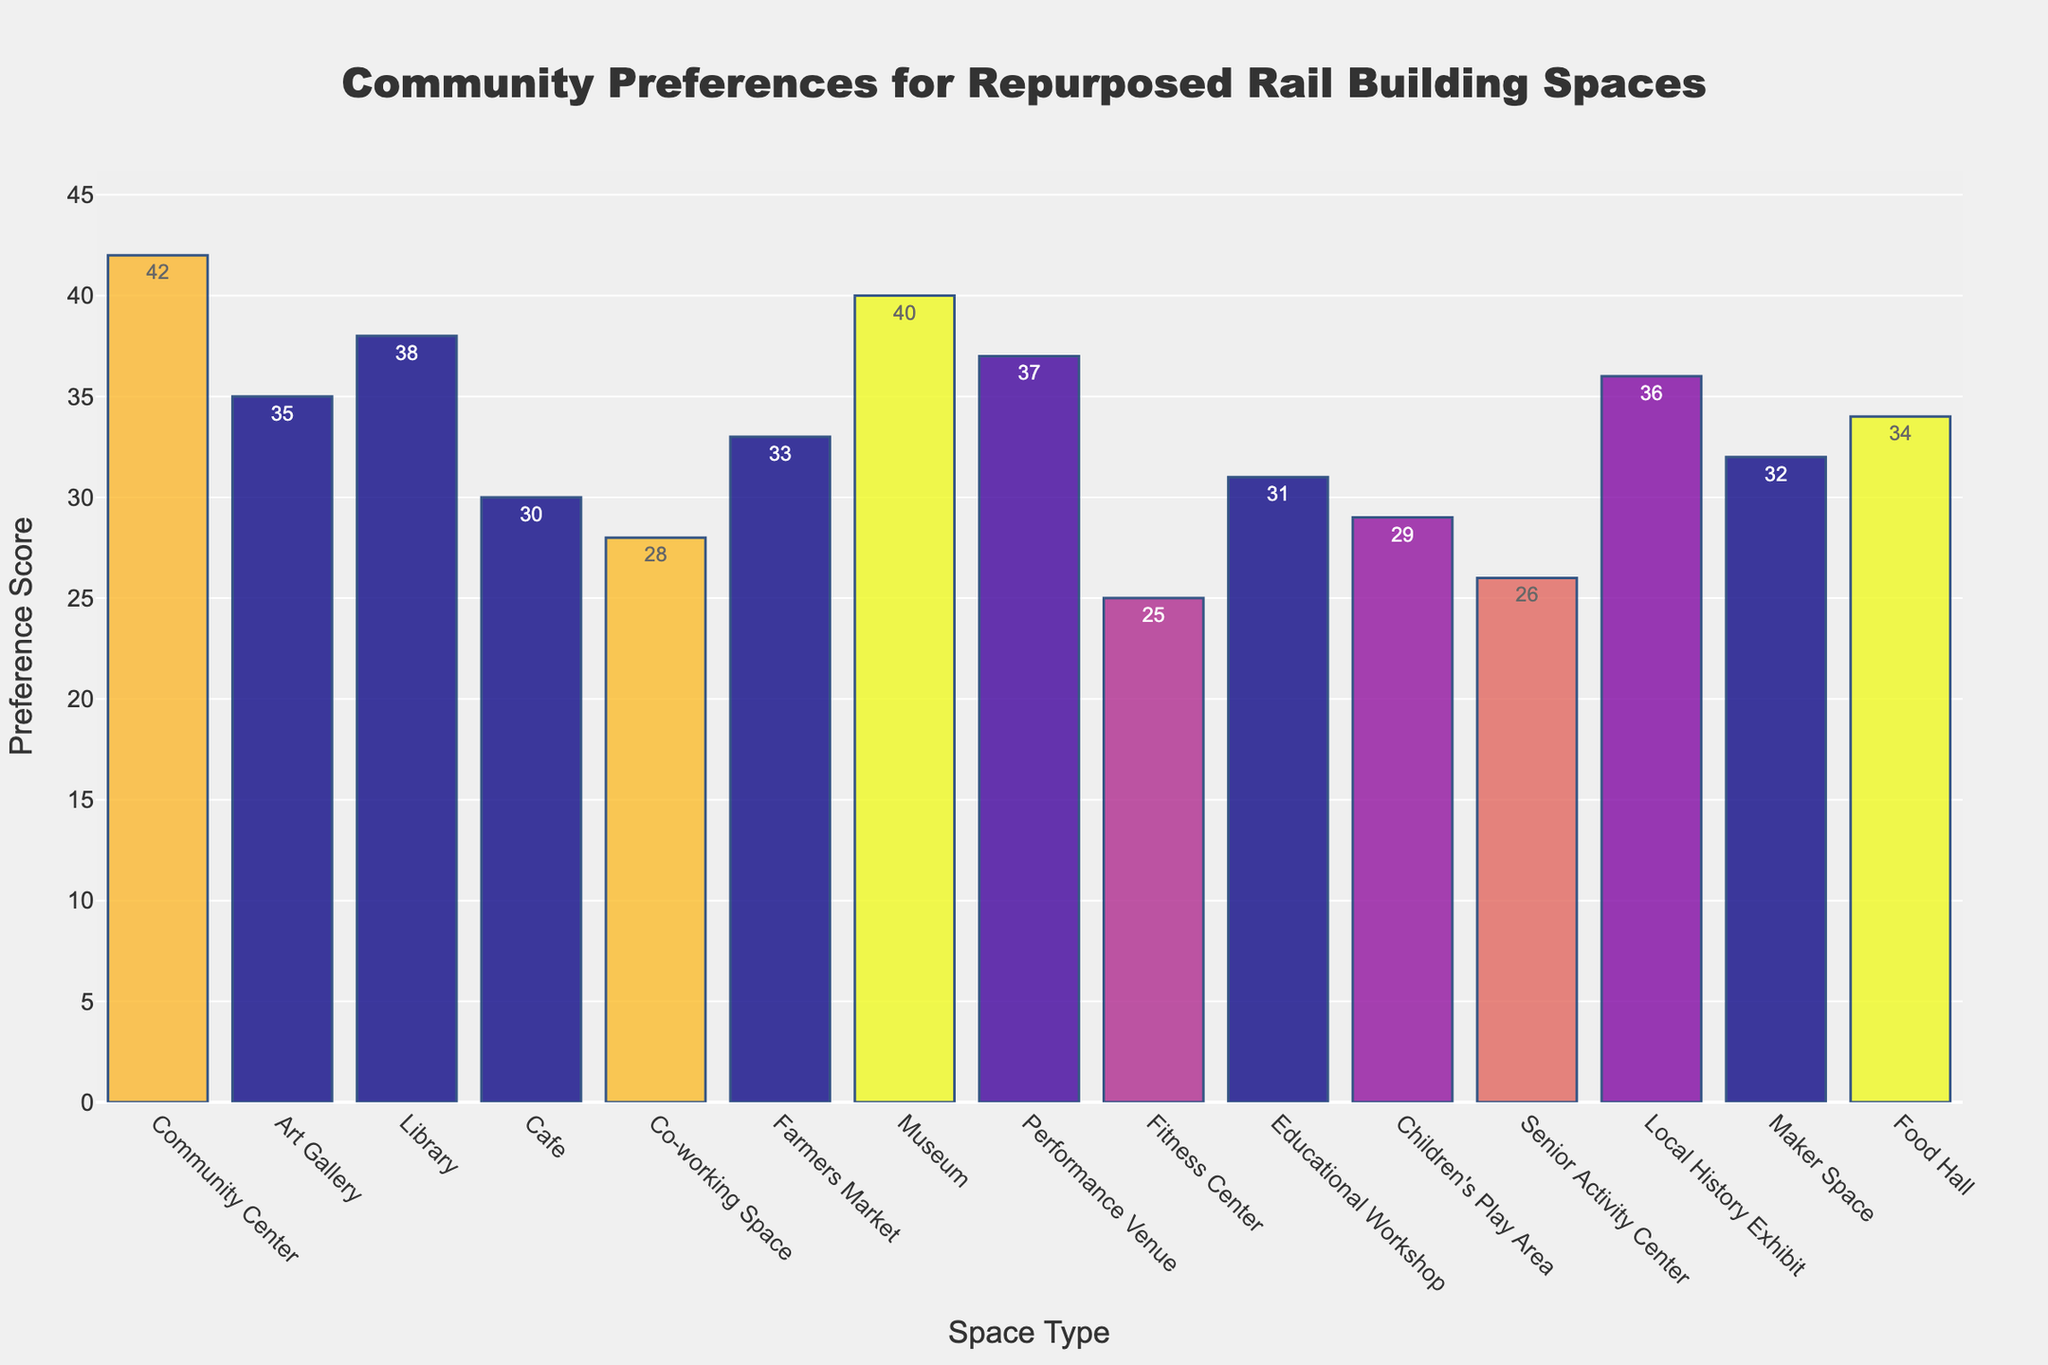What is the title of the figure? The title is positioned at the top of the figure, centered. It reads, "Community Preferences for Repurposed Rail Building Spaces".
Answer: Community Preferences for Repurposed Rail Building Spaces What are the axis labels in the figure? The x-axis is labeled "Space Type" and the y-axis is labeled "Preference Score". These labels indicate what each axis represents.
Answer: Space Type on x-axis and Preference Score on y-axis Which space type has the highest preference score? According to the bar heights, the Community Center has the highest bar, indicating the highest preference score.
Answer: Community Center Which space type has the lowest preference score? By looking for the shortest bar, the Fitness Center has the lowest preference score.
Answer: Fitness Center How many space types scored above 35 in preference? By inspecting the bars with heights above 35, there are five space types: Community Center, Art Gallery, Museum, Performance Venue, and Local History Exhibit.
Answer: 5 What is the difference in preference scores between the most and least preferred space types? The most preferred (Community Center) scores 42 and the least preferred (Fitness Center) scores 25. Subtracting these gives 42 - 25 = 17.
Answer: 17 What is the average preference score across all space types? Sum all the scores and divide by the total number of space types: (42 + 35 + 38 + 30 + 28 + 33 + 40 + 37 + 25 + 31 + 29 + 26 + 36 + 32 + 34) / 15 = 486 / 15 = 32.4.
Answer: 32.4 Which space type is exactly in the middle in terms of preference score? Organize the scores and find the median: Community Center (42), Museum (40), Performance Venue (37), Local History Exhibit (36), Art Gallery (35), Food Hall (34), Farmers Market (33), Maker Space (32), Educational Workshop (31), Cafe (30), Children's Play Area (29), Co-working Space (28), Senior Activity Center (26), Fitness Center (25). The median score (8th score) is 32, corresponding to the Maker Space.
Answer: Maker Space What is the combined preference score of all educational and cultural space types? Sum scores of Library, Museum, Educational Workshop, Local History Exhibit, and Art Gallery: 38 + 40 + 31 + 36 + 35 = 180.
Answer: 180 Which space type has a preference score closest to the overall average? The overall average is 32.4. The scores close to 32.4 are Maker Space (32), Educational Workshop (31), and Cafe (30). The closest score is 32 (Maker Space).
Answer: Maker Space 